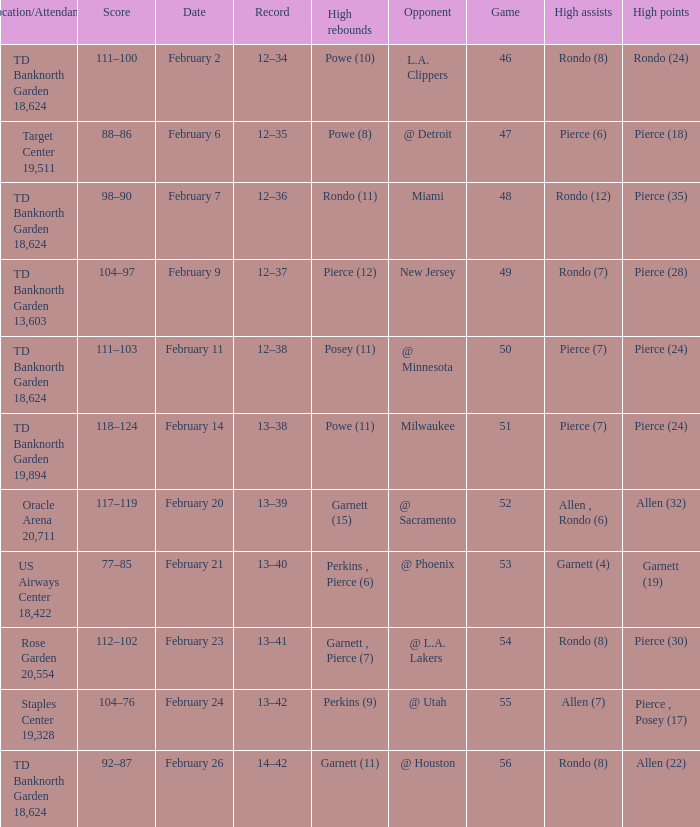Parse the full table. {'header': ['Location/Attendance', 'Score', 'Date', 'Record', 'High rebounds', 'Opponent', 'Game', 'High assists', 'High points'], 'rows': [['TD Banknorth Garden 18,624', '111–100', 'February 2', '12–34', 'Powe (10)', 'L.A. Clippers', '46', 'Rondo (8)', 'Rondo (24)'], ['Target Center 19,511', '88–86', 'February 6', '12–35', 'Powe (8)', '@ Detroit', '47', 'Pierce (6)', 'Pierce (18)'], ['TD Banknorth Garden 18,624', '98–90', 'February 7', '12–36', 'Rondo (11)', 'Miami', '48', 'Rondo (12)', 'Pierce (35)'], ['TD Banknorth Garden 13,603', '104–97', 'February 9', '12–37', 'Pierce (12)', 'New Jersey', '49', 'Rondo (7)', 'Pierce (28)'], ['TD Banknorth Garden 18,624', '111–103', 'February 11', '12–38', 'Posey (11)', '@ Minnesota', '50', 'Pierce (7)', 'Pierce (24)'], ['TD Banknorth Garden 19,894', '118–124', 'February 14', '13–38', 'Powe (11)', 'Milwaukee', '51', 'Pierce (7)', 'Pierce (24)'], ['Oracle Arena 20,711', '117–119', 'February 20', '13–39', 'Garnett (15)', '@ Sacramento', '52', 'Allen , Rondo (6)', 'Allen (32)'], ['US Airways Center 18,422', '77–85', 'February 21', '13–40', 'Perkins , Pierce (6)', '@ Phoenix', '53', 'Garnett (4)', 'Garnett (19)'], ['Rose Garden 20,554', '112–102', 'February 23', '13–41', 'Garnett , Pierce (7)', '@ L.A. Lakers', '54', 'Rondo (8)', 'Pierce (30)'], ['Staples Center 19,328', '104–76', 'February 24', '13–42', 'Perkins (9)', '@ Utah', '55', 'Allen (7)', 'Pierce , Posey (17)'], ['TD Banknorth Garden 18,624', '92–87', 'February 26', '14–42', 'Garnett (11)', '@ Houston', '56', 'Rondo (8)', 'Allen (22)']]} How many games with high rebounds where in february 26 1.0. 